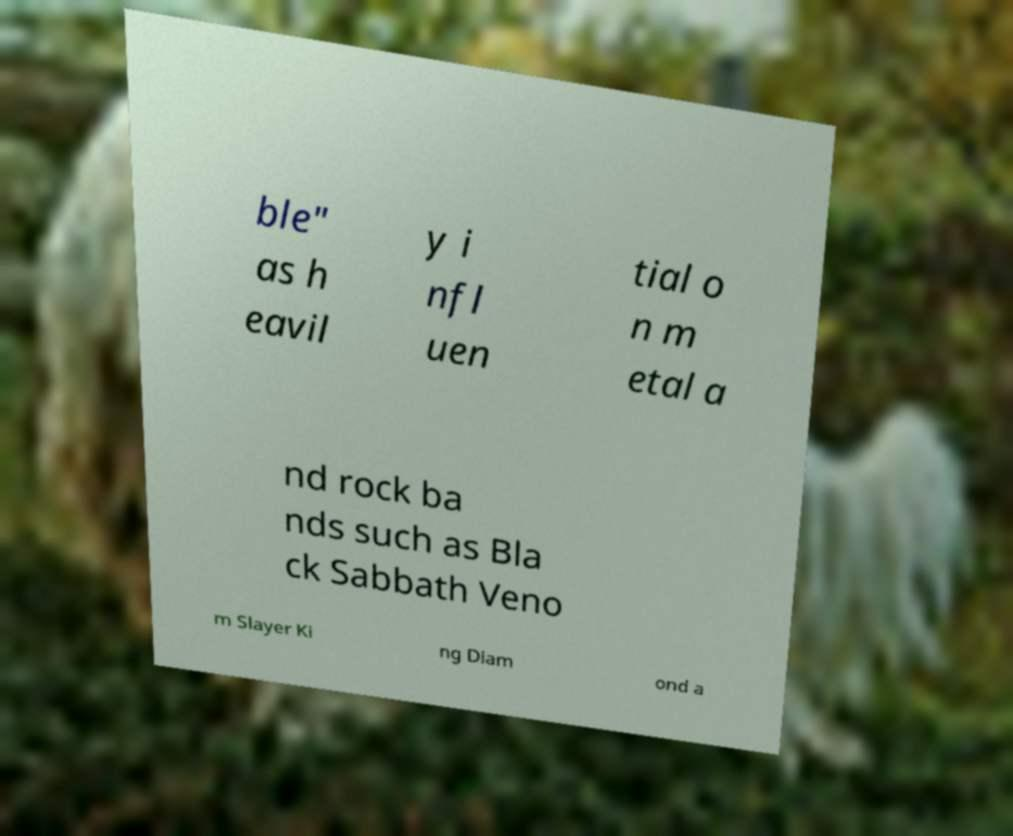Can you accurately transcribe the text from the provided image for me? ble" as h eavil y i nfl uen tial o n m etal a nd rock ba nds such as Bla ck Sabbath Veno m Slayer Ki ng Diam ond a 